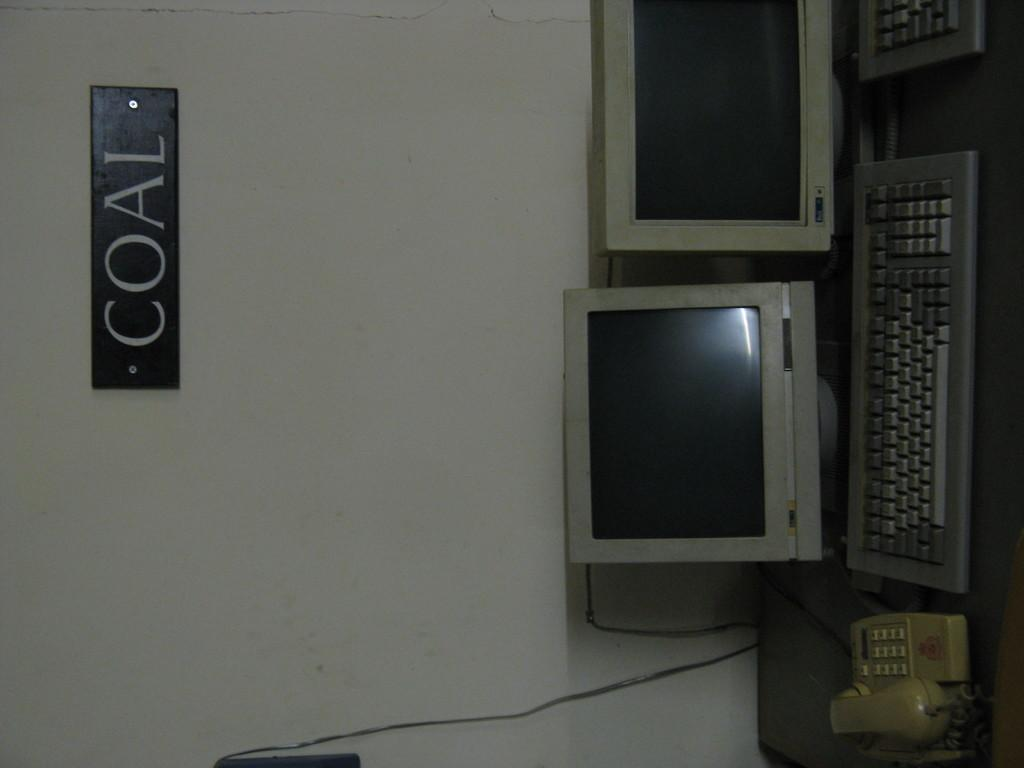<image>
Describe the image concisely. a sign on a wall that says coal on it 